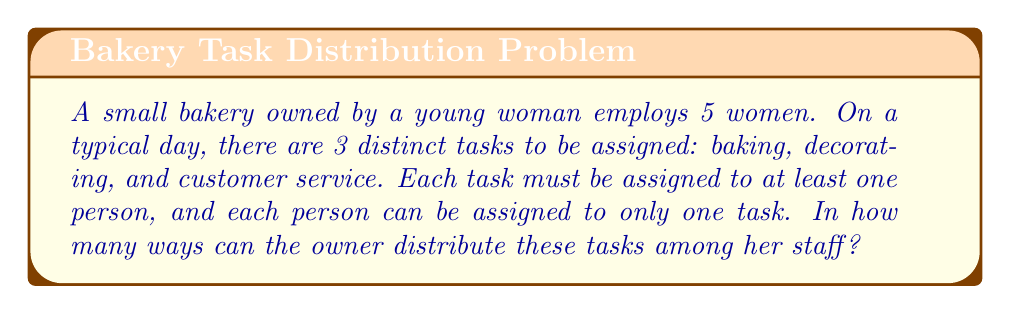Teach me how to tackle this problem. Let's approach this step-by-step using the concept of partitions and the multiplication principle.

1) First, we need to distribute 5 people into 3 non-empty groups (as each task must be assigned to at least one person). This is equivalent to finding the number of ways to partition 5 distinguishable objects into 3 non-empty subsets.

2) The number of ways to partition n distinguishable objects into k non-empty subsets is given by the Stirling number of the second kind, denoted as $\stirling{n}{k}$.

3) In this case, we need to calculate $\stirling{5}{3}$.

4) The formula for this Stirling number is:

   $$\stirling{5}{3} = \frac{1}{3!}\sum_{i=0}^3 (-1)^i \binom{3}{i}(3-i)^5$$

5) Let's calculate each term:
   For i = 0: $\binom{3}{0}(3-0)^5 = 1 \cdot 3^5 = 243$
   For i = 1: $\binom{3}{1}(3-1)^5 = 3 \cdot 2^5 = 96$
   For i = 2: $\binom{3}{2}(3-2)^5 = 3 \cdot 1^5 = 3$
   For i = 3: $\binom{3}{3}(3-3)^5 = 1 \cdot 0^5 = 0$

6) Summing up: $243 - 96 + 3 - 0 = 150$

7) Dividing by 3!: $150 / 6 = 25$

Therefore, there are 25 ways to distribute 5 distinguishable people into 3 non-empty groups.
Answer: There are 25 ways for the bakery owner to distribute the tasks among her staff. 